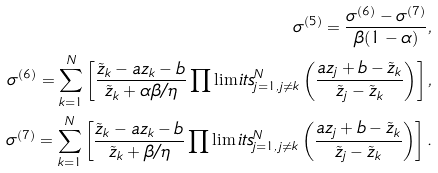Convert formula to latex. <formula><loc_0><loc_0><loc_500><loc_500>\sigma ^ { ( 5 ) } = \frac { \sigma ^ { ( 6 ) } - \sigma ^ { ( 7 ) } } { \beta ( 1 - \alpha ) } , \\ \sigma ^ { ( 6 ) } = \sum _ { k = 1 } ^ { N } \left [ \frac { \tilde { z } _ { k } - a z _ { k } - b } { \tilde { z } _ { k } + \alpha \beta / \eta } \prod \lim i t s _ { j = 1 , \, j \neq k } ^ { N } \left ( \frac { a z _ { j } + b - \tilde { z } _ { k } } { \tilde { z } _ { j } - \tilde { z } _ { k } } \right ) \right ] , \\ \sigma ^ { ( 7 ) } = \sum _ { k = 1 } ^ { N } \left [ \frac { \tilde { z } _ { k } - a z _ { k } - b } { \tilde { z } _ { k } + \beta / \eta } \prod \lim i t s _ { j = 1 , \, j \neq k } ^ { N } \left ( \frac { a z _ { j } + b - \tilde { z } _ { k } } { \tilde { z } _ { j } - \tilde { z } _ { k } } \right ) \right ] .</formula> 